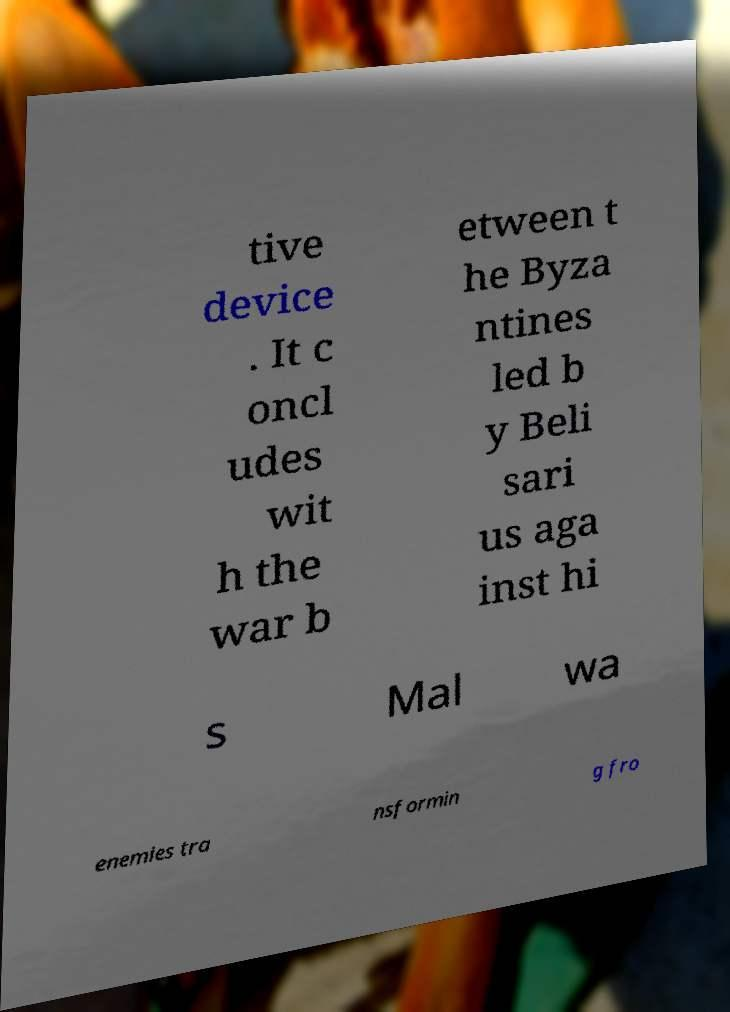Can you accurately transcribe the text from the provided image for me? tive device . It c oncl udes wit h the war b etween t he Byza ntines led b y Beli sari us aga inst hi s Mal wa enemies tra nsformin g fro 